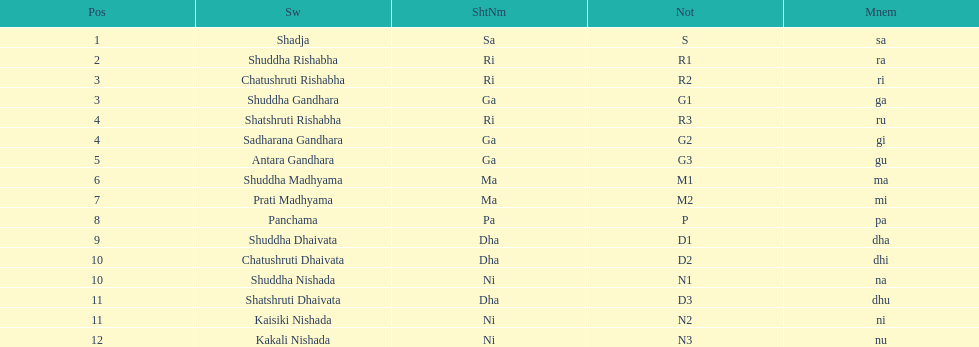Which swara can be found in the last place? Kakali Nishada. 